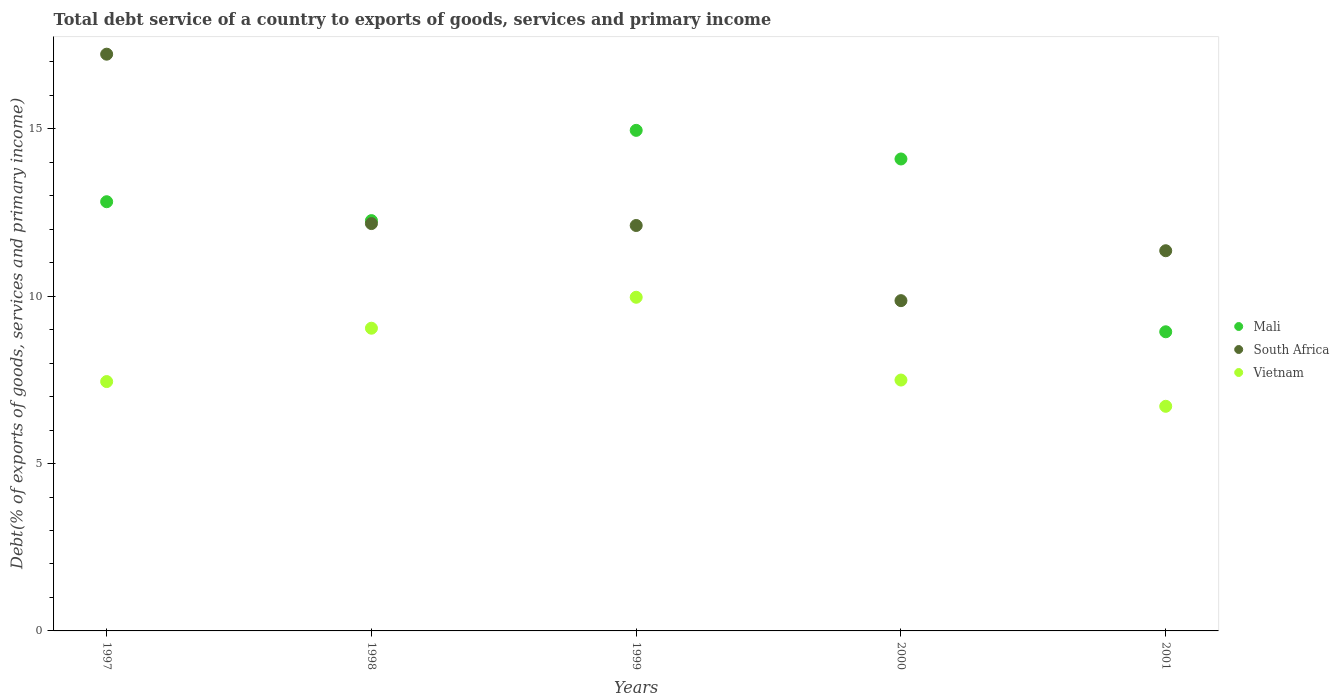How many different coloured dotlines are there?
Keep it short and to the point. 3. Is the number of dotlines equal to the number of legend labels?
Ensure brevity in your answer.  Yes. What is the total debt service in Mali in 1997?
Keep it short and to the point. 12.82. Across all years, what is the maximum total debt service in South Africa?
Give a very brief answer. 17.23. Across all years, what is the minimum total debt service in Mali?
Ensure brevity in your answer.  8.94. What is the total total debt service in South Africa in the graph?
Your answer should be compact. 62.75. What is the difference between the total debt service in South Africa in 1998 and that in 2000?
Ensure brevity in your answer.  2.3. What is the difference between the total debt service in Mali in 1998 and the total debt service in Vietnam in 1999?
Keep it short and to the point. 2.29. What is the average total debt service in Mali per year?
Provide a short and direct response. 12.62. In the year 1998, what is the difference between the total debt service in Mali and total debt service in South Africa?
Provide a short and direct response. 0.09. In how many years, is the total debt service in Mali greater than 16 %?
Offer a terse response. 0. What is the ratio of the total debt service in Vietnam in 2000 to that in 2001?
Make the answer very short. 1.12. Is the difference between the total debt service in Mali in 1997 and 1999 greater than the difference between the total debt service in South Africa in 1997 and 1999?
Ensure brevity in your answer.  No. What is the difference between the highest and the second highest total debt service in South Africa?
Offer a very short reply. 5.06. What is the difference between the highest and the lowest total debt service in South Africa?
Offer a terse response. 7.36. Is it the case that in every year, the sum of the total debt service in Vietnam and total debt service in South Africa  is greater than the total debt service in Mali?
Keep it short and to the point. Yes. Is the total debt service in South Africa strictly less than the total debt service in Vietnam over the years?
Your answer should be very brief. No. How many dotlines are there?
Keep it short and to the point. 3. What is the difference between two consecutive major ticks on the Y-axis?
Provide a succinct answer. 5. Are the values on the major ticks of Y-axis written in scientific E-notation?
Provide a succinct answer. No. Does the graph contain grids?
Ensure brevity in your answer.  No. What is the title of the graph?
Offer a very short reply. Total debt service of a country to exports of goods, services and primary income. What is the label or title of the X-axis?
Your answer should be very brief. Years. What is the label or title of the Y-axis?
Your answer should be very brief. Debt(% of exports of goods, services and primary income). What is the Debt(% of exports of goods, services and primary income) in Mali in 1997?
Provide a short and direct response. 12.82. What is the Debt(% of exports of goods, services and primary income) in South Africa in 1997?
Offer a terse response. 17.23. What is the Debt(% of exports of goods, services and primary income) of Vietnam in 1997?
Your response must be concise. 7.45. What is the Debt(% of exports of goods, services and primary income) of Mali in 1998?
Make the answer very short. 12.26. What is the Debt(% of exports of goods, services and primary income) of South Africa in 1998?
Your answer should be compact. 12.17. What is the Debt(% of exports of goods, services and primary income) of Vietnam in 1998?
Offer a terse response. 9.04. What is the Debt(% of exports of goods, services and primary income) in Mali in 1999?
Provide a short and direct response. 14.96. What is the Debt(% of exports of goods, services and primary income) in South Africa in 1999?
Offer a terse response. 12.11. What is the Debt(% of exports of goods, services and primary income) of Vietnam in 1999?
Keep it short and to the point. 9.97. What is the Debt(% of exports of goods, services and primary income) in Mali in 2000?
Offer a very short reply. 14.1. What is the Debt(% of exports of goods, services and primary income) in South Africa in 2000?
Make the answer very short. 9.87. What is the Debt(% of exports of goods, services and primary income) of Vietnam in 2000?
Offer a terse response. 7.5. What is the Debt(% of exports of goods, services and primary income) in Mali in 2001?
Make the answer very short. 8.94. What is the Debt(% of exports of goods, services and primary income) in South Africa in 2001?
Your answer should be very brief. 11.36. What is the Debt(% of exports of goods, services and primary income) in Vietnam in 2001?
Offer a terse response. 6.71. Across all years, what is the maximum Debt(% of exports of goods, services and primary income) in Mali?
Keep it short and to the point. 14.96. Across all years, what is the maximum Debt(% of exports of goods, services and primary income) in South Africa?
Make the answer very short. 17.23. Across all years, what is the maximum Debt(% of exports of goods, services and primary income) in Vietnam?
Provide a short and direct response. 9.97. Across all years, what is the minimum Debt(% of exports of goods, services and primary income) in Mali?
Your answer should be compact. 8.94. Across all years, what is the minimum Debt(% of exports of goods, services and primary income) of South Africa?
Provide a succinct answer. 9.87. Across all years, what is the minimum Debt(% of exports of goods, services and primary income) of Vietnam?
Provide a short and direct response. 6.71. What is the total Debt(% of exports of goods, services and primary income) of Mali in the graph?
Your answer should be very brief. 63.08. What is the total Debt(% of exports of goods, services and primary income) of South Africa in the graph?
Keep it short and to the point. 62.75. What is the total Debt(% of exports of goods, services and primary income) of Vietnam in the graph?
Your answer should be very brief. 40.67. What is the difference between the Debt(% of exports of goods, services and primary income) of Mali in 1997 and that in 1998?
Your answer should be very brief. 0.56. What is the difference between the Debt(% of exports of goods, services and primary income) of South Africa in 1997 and that in 1998?
Provide a short and direct response. 5.06. What is the difference between the Debt(% of exports of goods, services and primary income) of Vietnam in 1997 and that in 1998?
Provide a succinct answer. -1.59. What is the difference between the Debt(% of exports of goods, services and primary income) of Mali in 1997 and that in 1999?
Offer a very short reply. -2.13. What is the difference between the Debt(% of exports of goods, services and primary income) in South Africa in 1997 and that in 1999?
Ensure brevity in your answer.  5.12. What is the difference between the Debt(% of exports of goods, services and primary income) of Vietnam in 1997 and that in 1999?
Offer a terse response. -2.52. What is the difference between the Debt(% of exports of goods, services and primary income) of Mali in 1997 and that in 2000?
Offer a very short reply. -1.28. What is the difference between the Debt(% of exports of goods, services and primary income) of South Africa in 1997 and that in 2000?
Ensure brevity in your answer.  7.36. What is the difference between the Debt(% of exports of goods, services and primary income) of Vietnam in 1997 and that in 2000?
Make the answer very short. -0.05. What is the difference between the Debt(% of exports of goods, services and primary income) of Mali in 1997 and that in 2001?
Your answer should be very brief. 3.89. What is the difference between the Debt(% of exports of goods, services and primary income) in South Africa in 1997 and that in 2001?
Offer a terse response. 5.87. What is the difference between the Debt(% of exports of goods, services and primary income) of Vietnam in 1997 and that in 2001?
Provide a succinct answer. 0.74. What is the difference between the Debt(% of exports of goods, services and primary income) in Mali in 1998 and that in 1999?
Keep it short and to the point. -2.7. What is the difference between the Debt(% of exports of goods, services and primary income) of South Africa in 1998 and that in 1999?
Offer a terse response. 0.06. What is the difference between the Debt(% of exports of goods, services and primary income) of Vietnam in 1998 and that in 1999?
Give a very brief answer. -0.93. What is the difference between the Debt(% of exports of goods, services and primary income) in Mali in 1998 and that in 2000?
Offer a very short reply. -1.84. What is the difference between the Debt(% of exports of goods, services and primary income) in South Africa in 1998 and that in 2000?
Make the answer very short. 2.3. What is the difference between the Debt(% of exports of goods, services and primary income) in Vietnam in 1998 and that in 2000?
Give a very brief answer. 1.55. What is the difference between the Debt(% of exports of goods, services and primary income) in Mali in 1998 and that in 2001?
Your response must be concise. 3.32. What is the difference between the Debt(% of exports of goods, services and primary income) in South Africa in 1998 and that in 2001?
Your answer should be compact. 0.81. What is the difference between the Debt(% of exports of goods, services and primary income) of Vietnam in 1998 and that in 2001?
Ensure brevity in your answer.  2.33. What is the difference between the Debt(% of exports of goods, services and primary income) of Mali in 1999 and that in 2000?
Give a very brief answer. 0.86. What is the difference between the Debt(% of exports of goods, services and primary income) of South Africa in 1999 and that in 2000?
Give a very brief answer. 2.25. What is the difference between the Debt(% of exports of goods, services and primary income) in Vietnam in 1999 and that in 2000?
Your response must be concise. 2.47. What is the difference between the Debt(% of exports of goods, services and primary income) in Mali in 1999 and that in 2001?
Your answer should be compact. 6.02. What is the difference between the Debt(% of exports of goods, services and primary income) in South Africa in 1999 and that in 2001?
Your answer should be very brief. 0.75. What is the difference between the Debt(% of exports of goods, services and primary income) of Vietnam in 1999 and that in 2001?
Ensure brevity in your answer.  3.26. What is the difference between the Debt(% of exports of goods, services and primary income) in Mali in 2000 and that in 2001?
Make the answer very short. 5.16. What is the difference between the Debt(% of exports of goods, services and primary income) of South Africa in 2000 and that in 2001?
Your answer should be very brief. -1.49. What is the difference between the Debt(% of exports of goods, services and primary income) in Vietnam in 2000 and that in 2001?
Provide a succinct answer. 0.78. What is the difference between the Debt(% of exports of goods, services and primary income) of Mali in 1997 and the Debt(% of exports of goods, services and primary income) of South Africa in 1998?
Your response must be concise. 0.65. What is the difference between the Debt(% of exports of goods, services and primary income) of Mali in 1997 and the Debt(% of exports of goods, services and primary income) of Vietnam in 1998?
Your answer should be very brief. 3.78. What is the difference between the Debt(% of exports of goods, services and primary income) of South Africa in 1997 and the Debt(% of exports of goods, services and primary income) of Vietnam in 1998?
Your response must be concise. 8.19. What is the difference between the Debt(% of exports of goods, services and primary income) of Mali in 1997 and the Debt(% of exports of goods, services and primary income) of South Africa in 1999?
Your answer should be compact. 0.71. What is the difference between the Debt(% of exports of goods, services and primary income) of Mali in 1997 and the Debt(% of exports of goods, services and primary income) of Vietnam in 1999?
Keep it short and to the point. 2.85. What is the difference between the Debt(% of exports of goods, services and primary income) of South Africa in 1997 and the Debt(% of exports of goods, services and primary income) of Vietnam in 1999?
Provide a succinct answer. 7.26. What is the difference between the Debt(% of exports of goods, services and primary income) of Mali in 1997 and the Debt(% of exports of goods, services and primary income) of South Africa in 2000?
Offer a very short reply. 2.96. What is the difference between the Debt(% of exports of goods, services and primary income) in Mali in 1997 and the Debt(% of exports of goods, services and primary income) in Vietnam in 2000?
Make the answer very short. 5.33. What is the difference between the Debt(% of exports of goods, services and primary income) of South Africa in 1997 and the Debt(% of exports of goods, services and primary income) of Vietnam in 2000?
Offer a terse response. 9.74. What is the difference between the Debt(% of exports of goods, services and primary income) in Mali in 1997 and the Debt(% of exports of goods, services and primary income) in South Africa in 2001?
Offer a very short reply. 1.46. What is the difference between the Debt(% of exports of goods, services and primary income) of Mali in 1997 and the Debt(% of exports of goods, services and primary income) of Vietnam in 2001?
Ensure brevity in your answer.  6.11. What is the difference between the Debt(% of exports of goods, services and primary income) in South Africa in 1997 and the Debt(% of exports of goods, services and primary income) in Vietnam in 2001?
Provide a short and direct response. 10.52. What is the difference between the Debt(% of exports of goods, services and primary income) in Mali in 1998 and the Debt(% of exports of goods, services and primary income) in South Africa in 1999?
Provide a short and direct response. 0.15. What is the difference between the Debt(% of exports of goods, services and primary income) of Mali in 1998 and the Debt(% of exports of goods, services and primary income) of Vietnam in 1999?
Your answer should be very brief. 2.29. What is the difference between the Debt(% of exports of goods, services and primary income) of South Africa in 1998 and the Debt(% of exports of goods, services and primary income) of Vietnam in 1999?
Provide a succinct answer. 2.2. What is the difference between the Debt(% of exports of goods, services and primary income) in Mali in 1998 and the Debt(% of exports of goods, services and primary income) in South Africa in 2000?
Offer a terse response. 2.39. What is the difference between the Debt(% of exports of goods, services and primary income) of Mali in 1998 and the Debt(% of exports of goods, services and primary income) of Vietnam in 2000?
Provide a succinct answer. 4.76. What is the difference between the Debt(% of exports of goods, services and primary income) of South Africa in 1998 and the Debt(% of exports of goods, services and primary income) of Vietnam in 2000?
Make the answer very short. 4.68. What is the difference between the Debt(% of exports of goods, services and primary income) of Mali in 1998 and the Debt(% of exports of goods, services and primary income) of South Africa in 2001?
Give a very brief answer. 0.9. What is the difference between the Debt(% of exports of goods, services and primary income) in Mali in 1998 and the Debt(% of exports of goods, services and primary income) in Vietnam in 2001?
Provide a short and direct response. 5.55. What is the difference between the Debt(% of exports of goods, services and primary income) of South Africa in 1998 and the Debt(% of exports of goods, services and primary income) of Vietnam in 2001?
Your answer should be compact. 5.46. What is the difference between the Debt(% of exports of goods, services and primary income) of Mali in 1999 and the Debt(% of exports of goods, services and primary income) of South Africa in 2000?
Make the answer very short. 5.09. What is the difference between the Debt(% of exports of goods, services and primary income) of Mali in 1999 and the Debt(% of exports of goods, services and primary income) of Vietnam in 2000?
Keep it short and to the point. 7.46. What is the difference between the Debt(% of exports of goods, services and primary income) of South Africa in 1999 and the Debt(% of exports of goods, services and primary income) of Vietnam in 2000?
Ensure brevity in your answer.  4.62. What is the difference between the Debt(% of exports of goods, services and primary income) of Mali in 1999 and the Debt(% of exports of goods, services and primary income) of South Africa in 2001?
Ensure brevity in your answer.  3.6. What is the difference between the Debt(% of exports of goods, services and primary income) in Mali in 1999 and the Debt(% of exports of goods, services and primary income) in Vietnam in 2001?
Keep it short and to the point. 8.25. What is the difference between the Debt(% of exports of goods, services and primary income) of South Africa in 1999 and the Debt(% of exports of goods, services and primary income) of Vietnam in 2001?
Provide a short and direct response. 5.4. What is the difference between the Debt(% of exports of goods, services and primary income) of Mali in 2000 and the Debt(% of exports of goods, services and primary income) of South Africa in 2001?
Your answer should be compact. 2.74. What is the difference between the Debt(% of exports of goods, services and primary income) of Mali in 2000 and the Debt(% of exports of goods, services and primary income) of Vietnam in 2001?
Your answer should be compact. 7.39. What is the difference between the Debt(% of exports of goods, services and primary income) in South Africa in 2000 and the Debt(% of exports of goods, services and primary income) in Vietnam in 2001?
Provide a short and direct response. 3.16. What is the average Debt(% of exports of goods, services and primary income) in Mali per year?
Provide a short and direct response. 12.62. What is the average Debt(% of exports of goods, services and primary income) in South Africa per year?
Make the answer very short. 12.55. What is the average Debt(% of exports of goods, services and primary income) in Vietnam per year?
Your answer should be very brief. 8.13. In the year 1997, what is the difference between the Debt(% of exports of goods, services and primary income) in Mali and Debt(% of exports of goods, services and primary income) in South Africa?
Give a very brief answer. -4.41. In the year 1997, what is the difference between the Debt(% of exports of goods, services and primary income) of Mali and Debt(% of exports of goods, services and primary income) of Vietnam?
Give a very brief answer. 5.37. In the year 1997, what is the difference between the Debt(% of exports of goods, services and primary income) in South Africa and Debt(% of exports of goods, services and primary income) in Vietnam?
Ensure brevity in your answer.  9.78. In the year 1998, what is the difference between the Debt(% of exports of goods, services and primary income) of Mali and Debt(% of exports of goods, services and primary income) of South Africa?
Your response must be concise. 0.09. In the year 1998, what is the difference between the Debt(% of exports of goods, services and primary income) in Mali and Debt(% of exports of goods, services and primary income) in Vietnam?
Provide a short and direct response. 3.22. In the year 1998, what is the difference between the Debt(% of exports of goods, services and primary income) in South Africa and Debt(% of exports of goods, services and primary income) in Vietnam?
Offer a very short reply. 3.13. In the year 1999, what is the difference between the Debt(% of exports of goods, services and primary income) of Mali and Debt(% of exports of goods, services and primary income) of South Africa?
Offer a terse response. 2.84. In the year 1999, what is the difference between the Debt(% of exports of goods, services and primary income) of Mali and Debt(% of exports of goods, services and primary income) of Vietnam?
Provide a short and direct response. 4.99. In the year 1999, what is the difference between the Debt(% of exports of goods, services and primary income) of South Africa and Debt(% of exports of goods, services and primary income) of Vietnam?
Ensure brevity in your answer.  2.14. In the year 2000, what is the difference between the Debt(% of exports of goods, services and primary income) in Mali and Debt(% of exports of goods, services and primary income) in South Africa?
Offer a very short reply. 4.23. In the year 2000, what is the difference between the Debt(% of exports of goods, services and primary income) of Mali and Debt(% of exports of goods, services and primary income) of Vietnam?
Your answer should be compact. 6.61. In the year 2000, what is the difference between the Debt(% of exports of goods, services and primary income) of South Africa and Debt(% of exports of goods, services and primary income) of Vietnam?
Give a very brief answer. 2.37. In the year 2001, what is the difference between the Debt(% of exports of goods, services and primary income) of Mali and Debt(% of exports of goods, services and primary income) of South Africa?
Offer a terse response. -2.42. In the year 2001, what is the difference between the Debt(% of exports of goods, services and primary income) in Mali and Debt(% of exports of goods, services and primary income) in Vietnam?
Offer a very short reply. 2.23. In the year 2001, what is the difference between the Debt(% of exports of goods, services and primary income) in South Africa and Debt(% of exports of goods, services and primary income) in Vietnam?
Give a very brief answer. 4.65. What is the ratio of the Debt(% of exports of goods, services and primary income) in Mali in 1997 to that in 1998?
Ensure brevity in your answer.  1.05. What is the ratio of the Debt(% of exports of goods, services and primary income) of South Africa in 1997 to that in 1998?
Your response must be concise. 1.42. What is the ratio of the Debt(% of exports of goods, services and primary income) of Vietnam in 1997 to that in 1998?
Ensure brevity in your answer.  0.82. What is the ratio of the Debt(% of exports of goods, services and primary income) in Mali in 1997 to that in 1999?
Keep it short and to the point. 0.86. What is the ratio of the Debt(% of exports of goods, services and primary income) in South Africa in 1997 to that in 1999?
Provide a succinct answer. 1.42. What is the ratio of the Debt(% of exports of goods, services and primary income) in Vietnam in 1997 to that in 1999?
Your answer should be very brief. 0.75. What is the ratio of the Debt(% of exports of goods, services and primary income) in Mali in 1997 to that in 2000?
Your response must be concise. 0.91. What is the ratio of the Debt(% of exports of goods, services and primary income) in South Africa in 1997 to that in 2000?
Provide a succinct answer. 1.75. What is the ratio of the Debt(% of exports of goods, services and primary income) of Vietnam in 1997 to that in 2000?
Your response must be concise. 0.99. What is the ratio of the Debt(% of exports of goods, services and primary income) in Mali in 1997 to that in 2001?
Offer a terse response. 1.43. What is the ratio of the Debt(% of exports of goods, services and primary income) in South Africa in 1997 to that in 2001?
Your response must be concise. 1.52. What is the ratio of the Debt(% of exports of goods, services and primary income) of Vietnam in 1997 to that in 2001?
Your response must be concise. 1.11. What is the ratio of the Debt(% of exports of goods, services and primary income) in Mali in 1998 to that in 1999?
Provide a short and direct response. 0.82. What is the ratio of the Debt(% of exports of goods, services and primary income) of Vietnam in 1998 to that in 1999?
Give a very brief answer. 0.91. What is the ratio of the Debt(% of exports of goods, services and primary income) of Mali in 1998 to that in 2000?
Give a very brief answer. 0.87. What is the ratio of the Debt(% of exports of goods, services and primary income) in South Africa in 1998 to that in 2000?
Keep it short and to the point. 1.23. What is the ratio of the Debt(% of exports of goods, services and primary income) in Vietnam in 1998 to that in 2000?
Provide a succinct answer. 1.21. What is the ratio of the Debt(% of exports of goods, services and primary income) of Mali in 1998 to that in 2001?
Give a very brief answer. 1.37. What is the ratio of the Debt(% of exports of goods, services and primary income) in South Africa in 1998 to that in 2001?
Make the answer very short. 1.07. What is the ratio of the Debt(% of exports of goods, services and primary income) in Vietnam in 1998 to that in 2001?
Your response must be concise. 1.35. What is the ratio of the Debt(% of exports of goods, services and primary income) of Mali in 1999 to that in 2000?
Keep it short and to the point. 1.06. What is the ratio of the Debt(% of exports of goods, services and primary income) in South Africa in 1999 to that in 2000?
Your answer should be compact. 1.23. What is the ratio of the Debt(% of exports of goods, services and primary income) of Vietnam in 1999 to that in 2000?
Keep it short and to the point. 1.33. What is the ratio of the Debt(% of exports of goods, services and primary income) of Mali in 1999 to that in 2001?
Offer a very short reply. 1.67. What is the ratio of the Debt(% of exports of goods, services and primary income) in South Africa in 1999 to that in 2001?
Provide a short and direct response. 1.07. What is the ratio of the Debt(% of exports of goods, services and primary income) in Vietnam in 1999 to that in 2001?
Your response must be concise. 1.49. What is the ratio of the Debt(% of exports of goods, services and primary income) in Mali in 2000 to that in 2001?
Your answer should be compact. 1.58. What is the ratio of the Debt(% of exports of goods, services and primary income) in South Africa in 2000 to that in 2001?
Provide a succinct answer. 0.87. What is the ratio of the Debt(% of exports of goods, services and primary income) of Vietnam in 2000 to that in 2001?
Keep it short and to the point. 1.12. What is the difference between the highest and the second highest Debt(% of exports of goods, services and primary income) of Mali?
Offer a terse response. 0.86. What is the difference between the highest and the second highest Debt(% of exports of goods, services and primary income) in South Africa?
Ensure brevity in your answer.  5.06. What is the difference between the highest and the second highest Debt(% of exports of goods, services and primary income) in Vietnam?
Give a very brief answer. 0.93. What is the difference between the highest and the lowest Debt(% of exports of goods, services and primary income) in Mali?
Give a very brief answer. 6.02. What is the difference between the highest and the lowest Debt(% of exports of goods, services and primary income) in South Africa?
Offer a very short reply. 7.36. What is the difference between the highest and the lowest Debt(% of exports of goods, services and primary income) in Vietnam?
Keep it short and to the point. 3.26. 